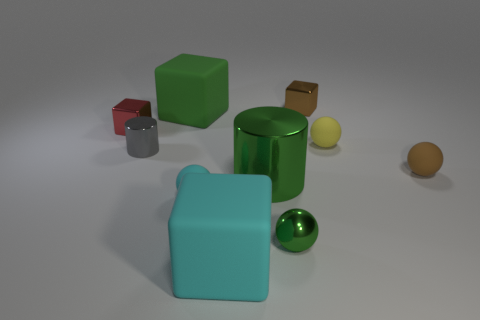Subtract 1 balls. How many balls are left? 3 Subtract all gray cubes. Subtract all yellow cylinders. How many cubes are left? 4 Subtract all balls. How many objects are left? 6 Subtract all big cylinders. Subtract all red matte cylinders. How many objects are left? 9 Add 2 small green objects. How many small green objects are left? 3 Add 2 tiny gray matte cylinders. How many tiny gray matte cylinders exist? 2 Subtract 1 brown balls. How many objects are left? 9 